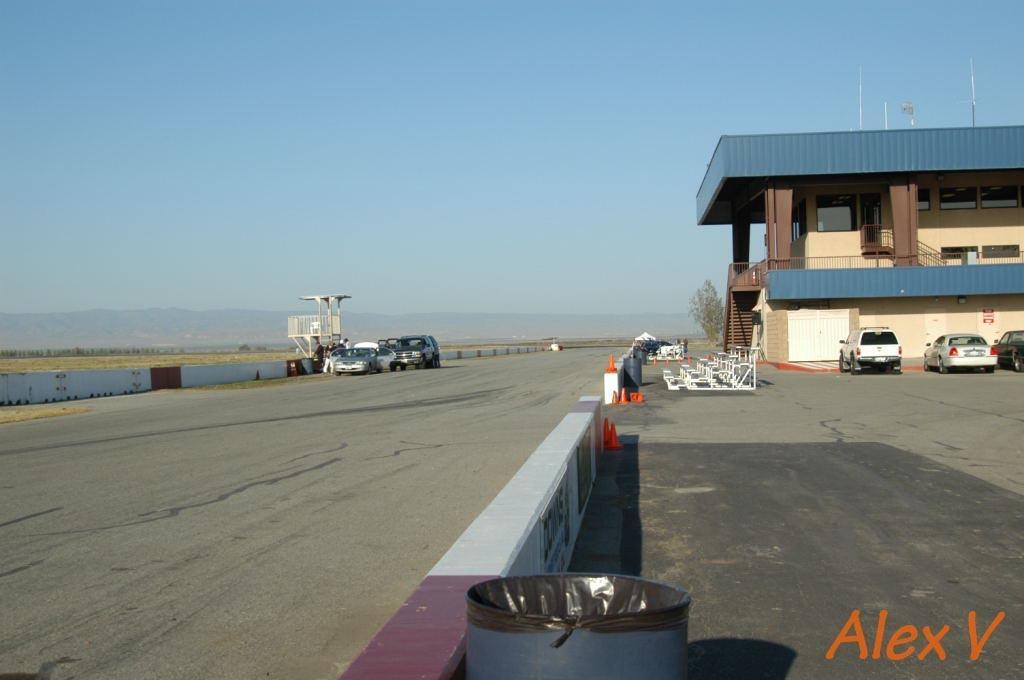Can you describe this image briefly? In the image there is a wide area and there are some vehicles parked in that area, on the right side there is a building and in the background there is a tree. 